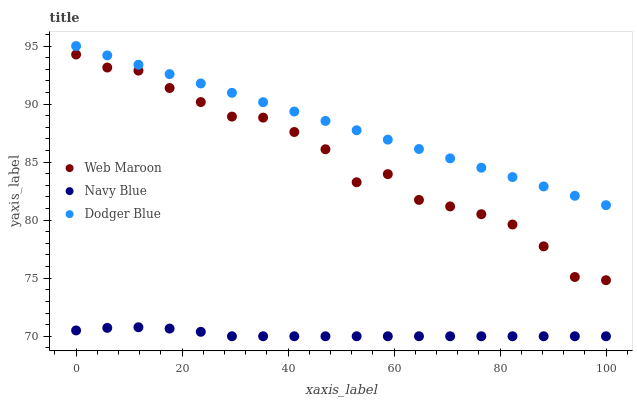Does Navy Blue have the minimum area under the curve?
Answer yes or no. Yes. Does Dodger Blue have the maximum area under the curve?
Answer yes or no. Yes. Does Web Maroon have the minimum area under the curve?
Answer yes or no. No. Does Web Maroon have the maximum area under the curve?
Answer yes or no. No. Is Dodger Blue the smoothest?
Answer yes or no. Yes. Is Web Maroon the roughest?
Answer yes or no. Yes. Is Web Maroon the smoothest?
Answer yes or no. No. Is Dodger Blue the roughest?
Answer yes or no. No. Does Navy Blue have the lowest value?
Answer yes or no. Yes. Does Web Maroon have the lowest value?
Answer yes or no. No. Does Dodger Blue have the highest value?
Answer yes or no. Yes. Does Web Maroon have the highest value?
Answer yes or no. No. Is Web Maroon less than Dodger Blue?
Answer yes or no. Yes. Is Dodger Blue greater than Navy Blue?
Answer yes or no. Yes. Does Web Maroon intersect Dodger Blue?
Answer yes or no. No. 